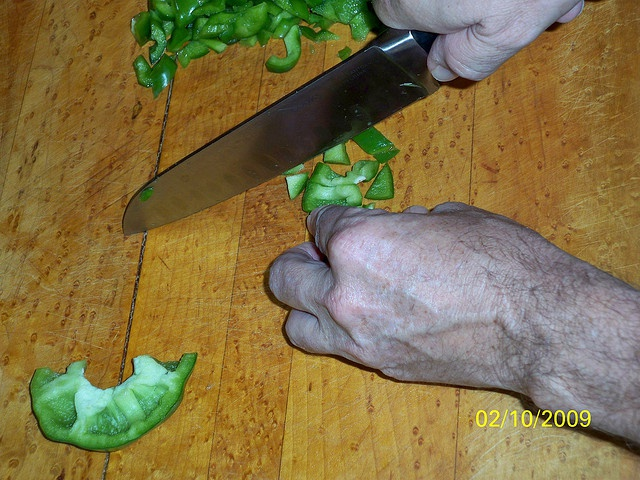Describe the objects in this image and their specific colors. I can see people in maroon, darkgray, and gray tones and knife in maroon, black, olive, and gray tones in this image. 